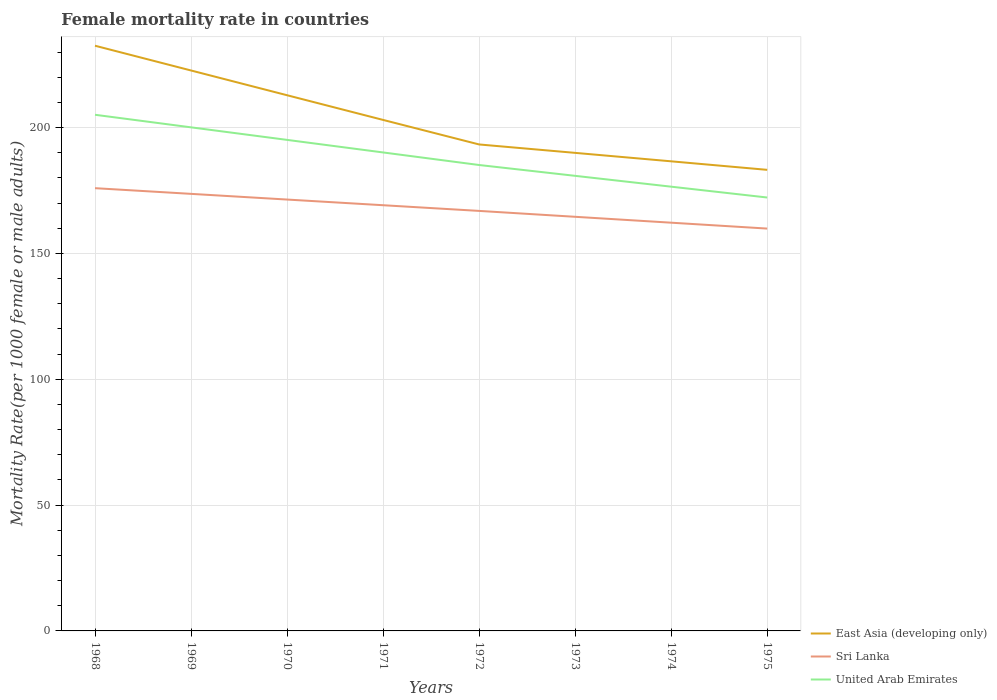Does the line corresponding to Sri Lanka intersect with the line corresponding to East Asia (developing only)?
Offer a very short reply. No. Across all years, what is the maximum female mortality rate in United Arab Emirates?
Make the answer very short. 172.23. In which year was the female mortality rate in Sri Lanka maximum?
Keep it short and to the point. 1975. What is the total female mortality rate in United Arab Emirates in the graph?
Your response must be concise. 12.92. What is the difference between the highest and the second highest female mortality rate in Sri Lanka?
Your answer should be compact. 16.06. What is the difference between the highest and the lowest female mortality rate in United Arab Emirates?
Ensure brevity in your answer.  4. Is the female mortality rate in Sri Lanka strictly greater than the female mortality rate in United Arab Emirates over the years?
Make the answer very short. Yes. How many years are there in the graph?
Give a very brief answer. 8. Are the values on the major ticks of Y-axis written in scientific E-notation?
Your answer should be very brief. No. Where does the legend appear in the graph?
Your answer should be compact. Bottom right. How are the legend labels stacked?
Give a very brief answer. Vertical. What is the title of the graph?
Provide a succinct answer. Female mortality rate in countries. What is the label or title of the X-axis?
Your answer should be very brief. Years. What is the label or title of the Y-axis?
Your answer should be compact. Mortality Rate(per 1000 female or male adults). What is the Mortality Rate(per 1000 female or male adults) in East Asia (developing only) in 1968?
Your answer should be compact. 232.55. What is the Mortality Rate(per 1000 female or male adults) of Sri Lanka in 1968?
Your answer should be very brief. 175.94. What is the Mortality Rate(per 1000 female or male adults) in United Arab Emirates in 1968?
Your answer should be very brief. 205.11. What is the Mortality Rate(per 1000 female or male adults) of East Asia (developing only) in 1969?
Your answer should be very brief. 222.71. What is the Mortality Rate(per 1000 female or male adults) of Sri Lanka in 1969?
Make the answer very short. 173.68. What is the Mortality Rate(per 1000 female or male adults) of United Arab Emirates in 1969?
Your answer should be compact. 200.12. What is the Mortality Rate(per 1000 female or male adults) in East Asia (developing only) in 1970?
Keep it short and to the point. 212.87. What is the Mortality Rate(per 1000 female or male adults) of Sri Lanka in 1970?
Make the answer very short. 171.43. What is the Mortality Rate(per 1000 female or male adults) of United Arab Emirates in 1970?
Give a very brief answer. 195.13. What is the Mortality Rate(per 1000 female or male adults) of East Asia (developing only) in 1971?
Your answer should be compact. 203.06. What is the Mortality Rate(per 1000 female or male adults) of Sri Lanka in 1971?
Your answer should be very brief. 169.17. What is the Mortality Rate(per 1000 female or male adults) of United Arab Emirates in 1971?
Make the answer very short. 190.14. What is the Mortality Rate(per 1000 female or male adults) in East Asia (developing only) in 1972?
Keep it short and to the point. 193.32. What is the Mortality Rate(per 1000 female or male adults) of Sri Lanka in 1972?
Keep it short and to the point. 166.91. What is the Mortality Rate(per 1000 female or male adults) in United Arab Emirates in 1972?
Keep it short and to the point. 185.15. What is the Mortality Rate(per 1000 female or male adults) in East Asia (developing only) in 1973?
Provide a short and direct response. 189.97. What is the Mortality Rate(per 1000 female or male adults) in Sri Lanka in 1973?
Your answer should be very brief. 164.57. What is the Mortality Rate(per 1000 female or male adults) of United Arab Emirates in 1973?
Provide a short and direct response. 180.84. What is the Mortality Rate(per 1000 female or male adults) of East Asia (developing only) in 1974?
Your response must be concise. 186.62. What is the Mortality Rate(per 1000 female or male adults) in Sri Lanka in 1974?
Your response must be concise. 162.23. What is the Mortality Rate(per 1000 female or male adults) in United Arab Emirates in 1974?
Provide a short and direct response. 176.54. What is the Mortality Rate(per 1000 female or male adults) in East Asia (developing only) in 1975?
Your response must be concise. 183.23. What is the Mortality Rate(per 1000 female or male adults) in Sri Lanka in 1975?
Your response must be concise. 159.89. What is the Mortality Rate(per 1000 female or male adults) of United Arab Emirates in 1975?
Provide a succinct answer. 172.23. Across all years, what is the maximum Mortality Rate(per 1000 female or male adults) in East Asia (developing only)?
Your answer should be compact. 232.55. Across all years, what is the maximum Mortality Rate(per 1000 female or male adults) in Sri Lanka?
Offer a terse response. 175.94. Across all years, what is the maximum Mortality Rate(per 1000 female or male adults) of United Arab Emirates?
Your answer should be very brief. 205.11. Across all years, what is the minimum Mortality Rate(per 1000 female or male adults) of East Asia (developing only)?
Offer a very short reply. 183.23. Across all years, what is the minimum Mortality Rate(per 1000 female or male adults) of Sri Lanka?
Offer a terse response. 159.89. Across all years, what is the minimum Mortality Rate(per 1000 female or male adults) of United Arab Emirates?
Offer a very short reply. 172.23. What is the total Mortality Rate(per 1000 female or male adults) in East Asia (developing only) in the graph?
Your answer should be very brief. 1624.33. What is the total Mortality Rate(per 1000 female or male adults) of Sri Lanka in the graph?
Make the answer very short. 1343.81. What is the total Mortality Rate(per 1000 female or male adults) of United Arab Emirates in the graph?
Make the answer very short. 1505.26. What is the difference between the Mortality Rate(per 1000 female or male adults) of East Asia (developing only) in 1968 and that in 1969?
Offer a terse response. 9.84. What is the difference between the Mortality Rate(per 1000 female or male adults) of Sri Lanka in 1968 and that in 1969?
Keep it short and to the point. 2.26. What is the difference between the Mortality Rate(per 1000 female or male adults) in United Arab Emirates in 1968 and that in 1969?
Your answer should be very brief. 4.99. What is the difference between the Mortality Rate(per 1000 female or male adults) in East Asia (developing only) in 1968 and that in 1970?
Keep it short and to the point. 19.68. What is the difference between the Mortality Rate(per 1000 female or male adults) in Sri Lanka in 1968 and that in 1970?
Ensure brevity in your answer.  4.52. What is the difference between the Mortality Rate(per 1000 female or male adults) in United Arab Emirates in 1968 and that in 1970?
Ensure brevity in your answer.  9.98. What is the difference between the Mortality Rate(per 1000 female or male adults) in East Asia (developing only) in 1968 and that in 1971?
Provide a short and direct response. 29.49. What is the difference between the Mortality Rate(per 1000 female or male adults) in Sri Lanka in 1968 and that in 1971?
Provide a succinct answer. 6.77. What is the difference between the Mortality Rate(per 1000 female or male adults) in United Arab Emirates in 1968 and that in 1971?
Give a very brief answer. 14.97. What is the difference between the Mortality Rate(per 1000 female or male adults) of East Asia (developing only) in 1968 and that in 1972?
Ensure brevity in your answer.  39.24. What is the difference between the Mortality Rate(per 1000 female or male adults) in Sri Lanka in 1968 and that in 1972?
Offer a terse response. 9.03. What is the difference between the Mortality Rate(per 1000 female or male adults) of United Arab Emirates in 1968 and that in 1972?
Provide a short and direct response. 19.96. What is the difference between the Mortality Rate(per 1000 female or male adults) in East Asia (developing only) in 1968 and that in 1973?
Your answer should be compact. 42.58. What is the difference between the Mortality Rate(per 1000 female or male adults) of Sri Lanka in 1968 and that in 1973?
Make the answer very short. 11.37. What is the difference between the Mortality Rate(per 1000 female or male adults) in United Arab Emirates in 1968 and that in 1973?
Offer a terse response. 24.27. What is the difference between the Mortality Rate(per 1000 female or male adults) in East Asia (developing only) in 1968 and that in 1974?
Give a very brief answer. 45.94. What is the difference between the Mortality Rate(per 1000 female or male adults) of Sri Lanka in 1968 and that in 1974?
Keep it short and to the point. 13.71. What is the difference between the Mortality Rate(per 1000 female or male adults) of United Arab Emirates in 1968 and that in 1974?
Provide a succinct answer. 28.57. What is the difference between the Mortality Rate(per 1000 female or male adults) in East Asia (developing only) in 1968 and that in 1975?
Your answer should be compact. 49.33. What is the difference between the Mortality Rate(per 1000 female or male adults) of Sri Lanka in 1968 and that in 1975?
Make the answer very short. 16.05. What is the difference between the Mortality Rate(per 1000 female or male adults) of United Arab Emirates in 1968 and that in 1975?
Your answer should be compact. 32.88. What is the difference between the Mortality Rate(per 1000 female or male adults) in East Asia (developing only) in 1969 and that in 1970?
Your answer should be compact. 9.83. What is the difference between the Mortality Rate(per 1000 female or male adults) in Sri Lanka in 1969 and that in 1970?
Offer a terse response. 2.26. What is the difference between the Mortality Rate(per 1000 female or male adults) of United Arab Emirates in 1969 and that in 1970?
Your answer should be compact. 4.99. What is the difference between the Mortality Rate(per 1000 female or male adults) in East Asia (developing only) in 1969 and that in 1971?
Offer a very short reply. 19.64. What is the difference between the Mortality Rate(per 1000 female or male adults) in Sri Lanka in 1969 and that in 1971?
Ensure brevity in your answer.  4.52. What is the difference between the Mortality Rate(per 1000 female or male adults) in United Arab Emirates in 1969 and that in 1971?
Ensure brevity in your answer.  9.98. What is the difference between the Mortality Rate(per 1000 female or male adults) of East Asia (developing only) in 1969 and that in 1972?
Offer a very short reply. 29.39. What is the difference between the Mortality Rate(per 1000 female or male adults) of Sri Lanka in 1969 and that in 1972?
Keep it short and to the point. 6.77. What is the difference between the Mortality Rate(per 1000 female or male adults) of United Arab Emirates in 1969 and that in 1972?
Ensure brevity in your answer.  14.97. What is the difference between the Mortality Rate(per 1000 female or male adults) of East Asia (developing only) in 1969 and that in 1973?
Provide a succinct answer. 32.73. What is the difference between the Mortality Rate(per 1000 female or male adults) of Sri Lanka in 1969 and that in 1973?
Your answer should be very brief. 9.12. What is the difference between the Mortality Rate(per 1000 female or male adults) of United Arab Emirates in 1969 and that in 1973?
Offer a terse response. 19.28. What is the difference between the Mortality Rate(per 1000 female or male adults) in East Asia (developing only) in 1969 and that in 1974?
Ensure brevity in your answer.  36.09. What is the difference between the Mortality Rate(per 1000 female or male adults) of Sri Lanka in 1969 and that in 1974?
Your response must be concise. 11.46. What is the difference between the Mortality Rate(per 1000 female or male adults) of United Arab Emirates in 1969 and that in 1974?
Ensure brevity in your answer.  23.58. What is the difference between the Mortality Rate(per 1000 female or male adults) of East Asia (developing only) in 1969 and that in 1975?
Provide a succinct answer. 39.48. What is the difference between the Mortality Rate(per 1000 female or male adults) in Sri Lanka in 1969 and that in 1975?
Offer a very short reply. 13.8. What is the difference between the Mortality Rate(per 1000 female or male adults) of United Arab Emirates in 1969 and that in 1975?
Your answer should be compact. 27.89. What is the difference between the Mortality Rate(per 1000 female or male adults) of East Asia (developing only) in 1970 and that in 1971?
Your answer should be compact. 9.81. What is the difference between the Mortality Rate(per 1000 female or male adults) in Sri Lanka in 1970 and that in 1971?
Offer a very short reply. 2.26. What is the difference between the Mortality Rate(per 1000 female or male adults) of United Arab Emirates in 1970 and that in 1971?
Provide a succinct answer. 4.99. What is the difference between the Mortality Rate(per 1000 female or male adults) of East Asia (developing only) in 1970 and that in 1972?
Provide a succinct answer. 19.56. What is the difference between the Mortality Rate(per 1000 female or male adults) of Sri Lanka in 1970 and that in 1972?
Provide a short and direct response. 4.52. What is the difference between the Mortality Rate(per 1000 female or male adults) of United Arab Emirates in 1970 and that in 1972?
Your answer should be compact. 9.98. What is the difference between the Mortality Rate(per 1000 female or male adults) of East Asia (developing only) in 1970 and that in 1973?
Offer a very short reply. 22.9. What is the difference between the Mortality Rate(per 1000 female or male adults) in Sri Lanka in 1970 and that in 1973?
Offer a very short reply. 6.86. What is the difference between the Mortality Rate(per 1000 female or male adults) in United Arab Emirates in 1970 and that in 1973?
Give a very brief answer. 14.29. What is the difference between the Mortality Rate(per 1000 female or male adults) in East Asia (developing only) in 1970 and that in 1974?
Your response must be concise. 26.26. What is the difference between the Mortality Rate(per 1000 female or male adults) of Sri Lanka in 1970 and that in 1974?
Your response must be concise. 9.2. What is the difference between the Mortality Rate(per 1000 female or male adults) in United Arab Emirates in 1970 and that in 1974?
Your answer should be very brief. 18.59. What is the difference between the Mortality Rate(per 1000 female or male adults) in East Asia (developing only) in 1970 and that in 1975?
Offer a terse response. 29.65. What is the difference between the Mortality Rate(per 1000 female or male adults) of Sri Lanka in 1970 and that in 1975?
Offer a terse response. 11.54. What is the difference between the Mortality Rate(per 1000 female or male adults) in United Arab Emirates in 1970 and that in 1975?
Make the answer very short. 22.9. What is the difference between the Mortality Rate(per 1000 female or male adults) in East Asia (developing only) in 1971 and that in 1972?
Offer a very short reply. 9.75. What is the difference between the Mortality Rate(per 1000 female or male adults) in Sri Lanka in 1971 and that in 1972?
Keep it short and to the point. 2.26. What is the difference between the Mortality Rate(per 1000 female or male adults) of United Arab Emirates in 1971 and that in 1972?
Provide a short and direct response. 4.99. What is the difference between the Mortality Rate(per 1000 female or male adults) in East Asia (developing only) in 1971 and that in 1973?
Offer a terse response. 13.09. What is the difference between the Mortality Rate(per 1000 female or male adults) of Sri Lanka in 1971 and that in 1973?
Provide a succinct answer. 4.6. What is the difference between the Mortality Rate(per 1000 female or male adults) in United Arab Emirates in 1971 and that in 1973?
Your answer should be very brief. 9.3. What is the difference between the Mortality Rate(per 1000 female or male adults) of East Asia (developing only) in 1971 and that in 1974?
Ensure brevity in your answer.  16.45. What is the difference between the Mortality Rate(per 1000 female or male adults) in Sri Lanka in 1971 and that in 1974?
Offer a very short reply. 6.94. What is the difference between the Mortality Rate(per 1000 female or male adults) of United Arab Emirates in 1971 and that in 1974?
Offer a very short reply. 13.6. What is the difference between the Mortality Rate(per 1000 female or male adults) of East Asia (developing only) in 1971 and that in 1975?
Your response must be concise. 19.84. What is the difference between the Mortality Rate(per 1000 female or male adults) of Sri Lanka in 1971 and that in 1975?
Your response must be concise. 9.28. What is the difference between the Mortality Rate(per 1000 female or male adults) in United Arab Emirates in 1971 and that in 1975?
Offer a very short reply. 17.91. What is the difference between the Mortality Rate(per 1000 female or male adults) in East Asia (developing only) in 1972 and that in 1973?
Your answer should be compact. 3.34. What is the difference between the Mortality Rate(per 1000 female or male adults) of Sri Lanka in 1972 and that in 1973?
Ensure brevity in your answer.  2.34. What is the difference between the Mortality Rate(per 1000 female or male adults) of United Arab Emirates in 1972 and that in 1973?
Offer a very short reply. 4.3. What is the difference between the Mortality Rate(per 1000 female or male adults) in East Asia (developing only) in 1972 and that in 1974?
Your answer should be compact. 6.7. What is the difference between the Mortality Rate(per 1000 female or male adults) in Sri Lanka in 1972 and that in 1974?
Make the answer very short. 4.68. What is the difference between the Mortality Rate(per 1000 female or male adults) in United Arab Emirates in 1972 and that in 1974?
Provide a short and direct response. 8.61. What is the difference between the Mortality Rate(per 1000 female or male adults) of East Asia (developing only) in 1972 and that in 1975?
Your answer should be very brief. 10.09. What is the difference between the Mortality Rate(per 1000 female or male adults) in Sri Lanka in 1972 and that in 1975?
Your answer should be very brief. 7.02. What is the difference between the Mortality Rate(per 1000 female or male adults) in United Arab Emirates in 1972 and that in 1975?
Provide a short and direct response. 12.92. What is the difference between the Mortality Rate(per 1000 female or male adults) of East Asia (developing only) in 1973 and that in 1974?
Provide a short and direct response. 3.36. What is the difference between the Mortality Rate(per 1000 female or male adults) in Sri Lanka in 1973 and that in 1974?
Provide a succinct answer. 2.34. What is the difference between the Mortality Rate(per 1000 female or male adults) in United Arab Emirates in 1973 and that in 1974?
Make the answer very short. 4.31. What is the difference between the Mortality Rate(per 1000 female or male adults) in East Asia (developing only) in 1973 and that in 1975?
Keep it short and to the point. 6.75. What is the difference between the Mortality Rate(per 1000 female or male adults) in Sri Lanka in 1973 and that in 1975?
Your answer should be compact. 4.68. What is the difference between the Mortality Rate(per 1000 female or male adults) of United Arab Emirates in 1973 and that in 1975?
Offer a terse response. 8.61. What is the difference between the Mortality Rate(per 1000 female or male adults) in East Asia (developing only) in 1974 and that in 1975?
Make the answer very short. 3.39. What is the difference between the Mortality Rate(per 1000 female or male adults) in Sri Lanka in 1974 and that in 1975?
Give a very brief answer. 2.34. What is the difference between the Mortality Rate(per 1000 female or male adults) in United Arab Emirates in 1974 and that in 1975?
Your answer should be very brief. 4.31. What is the difference between the Mortality Rate(per 1000 female or male adults) in East Asia (developing only) in 1968 and the Mortality Rate(per 1000 female or male adults) in Sri Lanka in 1969?
Your answer should be compact. 58.87. What is the difference between the Mortality Rate(per 1000 female or male adults) in East Asia (developing only) in 1968 and the Mortality Rate(per 1000 female or male adults) in United Arab Emirates in 1969?
Your answer should be very brief. 32.43. What is the difference between the Mortality Rate(per 1000 female or male adults) of Sri Lanka in 1968 and the Mortality Rate(per 1000 female or male adults) of United Arab Emirates in 1969?
Provide a succinct answer. -24.18. What is the difference between the Mortality Rate(per 1000 female or male adults) in East Asia (developing only) in 1968 and the Mortality Rate(per 1000 female or male adults) in Sri Lanka in 1970?
Provide a succinct answer. 61.13. What is the difference between the Mortality Rate(per 1000 female or male adults) in East Asia (developing only) in 1968 and the Mortality Rate(per 1000 female or male adults) in United Arab Emirates in 1970?
Offer a terse response. 37.42. What is the difference between the Mortality Rate(per 1000 female or male adults) of Sri Lanka in 1968 and the Mortality Rate(per 1000 female or male adults) of United Arab Emirates in 1970?
Your response must be concise. -19.19. What is the difference between the Mortality Rate(per 1000 female or male adults) in East Asia (developing only) in 1968 and the Mortality Rate(per 1000 female or male adults) in Sri Lanka in 1971?
Your answer should be compact. 63.39. What is the difference between the Mortality Rate(per 1000 female or male adults) in East Asia (developing only) in 1968 and the Mortality Rate(per 1000 female or male adults) in United Arab Emirates in 1971?
Ensure brevity in your answer.  42.41. What is the difference between the Mortality Rate(per 1000 female or male adults) in Sri Lanka in 1968 and the Mortality Rate(per 1000 female or male adults) in United Arab Emirates in 1971?
Offer a very short reply. -14.2. What is the difference between the Mortality Rate(per 1000 female or male adults) in East Asia (developing only) in 1968 and the Mortality Rate(per 1000 female or male adults) in Sri Lanka in 1972?
Ensure brevity in your answer.  65.64. What is the difference between the Mortality Rate(per 1000 female or male adults) of East Asia (developing only) in 1968 and the Mortality Rate(per 1000 female or male adults) of United Arab Emirates in 1972?
Ensure brevity in your answer.  47.4. What is the difference between the Mortality Rate(per 1000 female or male adults) of Sri Lanka in 1968 and the Mortality Rate(per 1000 female or male adults) of United Arab Emirates in 1972?
Ensure brevity in your answer.  -9.21. What is the difference between the Mortality Rate(per 1000 female or male adults) in East Asia (developing only) in 1968 and the Mortality Rate(per 1000 female or male adults) in Sri Lanka in 1973?
Provide a short and direct response. 67.98. What is the difference between the Mortality Rate(per 1000 female or male adults) of East Asia (developing only) in 1968 and the Mortality Rate(per 1000 female or male adults) of United Arab Emirates in 1973?
Give a very brief answer. 51.71. What is the difference between the Mortality Rate(per 1000 female or male adults) in Sri Lanka in 1968 and the Mortality Rate(per 1000 female or male adults) in United Arab Emirates in 1973?
Your answer should be compact. -4.9. What is the difference between the Mortality Rate(per 1000 female or male adults) in East Asia (developing only) in 1968 and the Mortality Rate(per 1000 female or male adults) in Sri Lanka in 1974?
Make the answer very short. 70.33. What is the difference between the Mortality Rate(per 1000 female or male adults) of East Asia (developing only) in 1968 and the Mortality Rate(per 1000 female or male adults) of United Arab Emirates in 1974?
Offer a very short reply. 56.02. What is the difference between the Mortality Rate(per 1000 female or male adults) of Sri Lanka in 1968 and the Mortality Rate(per 1000 female or male adults) of United Arab Emirates in 1974?
Keep it short and to the point. -0.6. What is the difference between the Mortality Rate(per 1000 female or male adults) in East Asia (developing only) in 1968 and the Mortality Rate(per 1000 female or male adults) in Sri Lanka in 1975?
Your response must be concise. 72.67. What is the difference between the Mortality Rate(per 1000 female or male adults) of East Asia (developing only) in 1968 and the Mortality Rate(per 1000 female or male adults) of United Arab Emirates in 1975?
Keep it short and to the point. 60.32. What is the difference between the Mortality Rate(per 1000 female or male adults) in Sri Lanka in 1968 and the Mortality Rate(per 1000 female or male adults) in United Arab Emirates in 1975?
Your response must be concise. 3.71. What is the difference between the Mortality Rate(per 1000 female or male adults) of East Asia (developing only) in 1969 and the Mortality Rate(per 1000 female or male adults) of Sri Lanka in 1970?
Your answer should be compact. 51.28. What is the difference between the Mortality Rate(per 1000 female or male adults) in East Asia (developing only) in 1969 and the Mortality Rate(per 1000 female or male adults) in United Arab Emirates in 1970?
Provide a short and direct response. 27.58. What is the difference between the Mortality Rate(per 1000 female or male adults) in Sri Lanka in 1969 and the Mortality Rate(per 1000 female or male adults) in United Arab Emirates in 1970?
Give a very brief answer. -21.45. What is the difference between the Mortality Rate(per 1000 female or male adults) of East Asia (developing only) in 1969 and the Mortality Rate(per 1000 female or male adults) of Sri Lanka in 1971?
Your response must be concise. 53.54. What is the difference between the Mortality Rate(per 1000 female or male adults) of East Asia (developing only) in 1969 and the Mortality Rate(per 1000 female or male adults) of United Arab Emirates in 1971?
Offer a very short reply. 32.57. What is the difference between the Mortality Rate(per 1000 female or male adults) of Sri Lanka in 1969 and the Mortality Rate(per 1000 female or male adults) of United Arab Emirates in 1971?
Offer a terse response. -16.46. What is the difference between the Mortality Rate(per 1000 female or male adults) of East Asia (developing only) in 1969 and the Mortality Rate(per 1000 female or male adults) of Sri Lanka in 1972?
Offer a terse response. 55.8. What is the difference between the Mortality Rate(per 1000 female or male adults) in East Asia (developing only) in 1969 and the Mortality Rate(per 1000 female or male adults) in United Arab Emirates in 1972?
Your answer should be compact. 37.56. What is the difference between the Mortality Rate(per 1000 female or male adults) of Sri Lanka in 1969 and the Mortality Rate(per 1000 female or male adults) of United Arab Emirates in 1972?
Your answer should be very brief. -11.46. What is the difference between the Mortality Rate(per 1000 female or male adults) in East Asia (developing only) in 1969 and the Mortality Rate(per 1000 female or male adults) in Sri Lanka in 1973?
Give a very brief answer. 58.14. What is the difference between the Mortality Rate(per 1000 female or male adults) in East Asia (developing only) in 1969 and the Mortality Rate(per 1000 female or male adults) in United Arab Emirates in 1973?
Provide a succinct answer. 41.87. What is the difference between the Mortality Rate(per 1000 female or male adults) in Sri Lanka in 1969 and the Mortality Rate(per 1000 female or male adults) in United Arab Emirates in 1973?
Keep it short and to the point. -7.16. What is the difference between the Mortality Rate(per 1000 female or male adults) in East Asia (developing only) in 1969 and the Mortality Rate(per 1000 female or male adults) in Sri Lanka in 1974?
Offer a terse response. 60.48. What is the difference between the Mortality Rate(per 1000 female or male adults) in East Asia (developing only) in 1969 and the Mortality Rate(per 1000 female or male adults) in United Arab Emirates in 1974?
Provide a succinct answer. 46.17. What is the difference between the Mortality Rate(per 1000 female or male adults) of Sri Lanka in 1969 and the Mortality Rate(per 1000 female or male adults) of United Arab Emirates in 1974?
Make the answer very short. -2.85. What is the difference between the Mortality Rate(per 1000 female or male adults) of East Asia (developing only) in 1969 and the Mortality Rate(per 1000 female or male adults) of Sri Lanka in 1975?
Give a very brief answer. 62.82. What is the difference between the Mortality Rate(per 1000 female or male adults) of East Asia (developing only) in 1969 and the Mortality Rate(per 1000 female or male adults) of United Arab Emirates in 1975?
Your response must be concise. 50.48. What is the difference between the Mortality Rate(per 1000 female or male adults) in Sri Lanka in 1969 and the Mortality Rate(per 1000 female or male adults) in United Arab Emirates in 1975?
Ensure brevity in your answer.  1.45. What is the difference between the Mortality Rate(per 1000 female or male adults) in East Asia (developing only) in 1970 and the Mortality Rate(per 1000 female or male adults) in Sri Lanka in 1971?
Keep it short and to the point. 43.71. What is the difference between the Mortality Rate(per 1000 female or male adults) in East Asia (developing only) in 1970 and the Mortality Rate(per 1000 female or male adults) in United Arab Emirates in 1971?
Keep it short and to the point. 22.73. What is the difference between the Mortality Rate(per 1000 female or male adults) in Sri Lanka in 1970 and the Mortality Rate(per 1000 female or male adults) in United Arab Emirates in 1971?
Your answer should be compact. -18.71. What is the difference between the Mortality Rate(per 1000 female or male adults) of East Asia (developing only) in 1970 and the Mortality Rate(per 1000 female or male adults) of Sri Lanka in 1972?
Keep it short and to the point. 45.97. What is the difference between the Mortality Rate(per 1000 female or male adults) in East Asia (developing only) in 1970 and the Mortality Rate(per 1000 female or male adults) in United Arab Emirates in 1972?
Offer a very short reply. 27.73. What is the difference between the Mortality Rate(per 1000 female or male adults) of Sri Lanka in 1970 and the Mortality Rate(per 1000 female or male adults) of United Arab Emirates in 1972?
Your answer should be very brief. -13.72. What is the difference between the Mortality Rate(per 1000 female or male adults) of East Asia (developing only) in 1970 and the Mortality Rate(per 1000 female or male adults) of Sri Lanka in 1973?
Keep it short and to the point. 48.31. What is the difference between the Mortality Rate(per 1000 female or male adults) in East Asia (developing only) in 1970 and the Mortality Rate(per 1000 female or male adults) in United Arab Emirates in 1973?
Your response must be concise. 32.03. What is the difference between the Mortality Rate(per 1000 female or male adults) in Sri Lanka in 1970 and the Mortality Rate(per 1000 female or male adults) in United Arab Emirates in 1973?
Provide a succinct answer. -9.42. What is the difference between the Mortality Rate(per 1000 female or male adults) in East Asia (developing only) in 1970 and the Mortality Rate(per 1000 female or male adults) in Sri Lanka in 1974?
Give a very brief answer. 50.65. What is the difference between the Mortality Rate(per 1000 female or male adults) in East Asia (developing only) in 1970 and the Mortality Rate(per 1000 female or male adults) in United Arab Emirates in 1974?
Your answer should be very brief. 36.34. What is the difference between the Mortality Rate(per 1000 female or male adults) in Sri Lanka in 1970 and the Mortality Rate(per 1000 female or male adults) in United Arab Emirates in 1974?
Offer a very short reply. -5.11. What is the difference between the Mortality Rate(per 1000 female or male adults) in East Asia (developing only) in 1970 and the Mortality Rate(per 1000 female or male adults) in Sri Lanka in 1975?
Your answer should be compact. 52.99. What is the difference between the Mortality Rate(per 1000 female or male adults) in East Asia (developing only) in 1970 and the Mortality Rate(per 1000 female or male adults) in United Arab Emirates in 1975?
Your answer should be very brief. 40.64. What is the difference between the Mortality Rate(per 1000 female or male adults) of Sri Lanka in 1970 and the Mortality Rate(per 1000 female or male adults) of United Arab Emirates in 1975?
Offer a very short reply. -0.81. What is the difference between the Mortality Rate(per 1000 female or male adults) in East Asia (developing only) in 1971 and the Mortality Rate(per 1000 female or male adults) in Sri Lanka in 1972?
Offer a terse response. 36.15. What is the difference between the Mortality Rate(per 1000 female or male adults) in East Asia (developing only) in 1971 and the Mortality Rate(per 1000 female or male adults) in United Arab Emirates in 1972?
Offer a terse response. 17.92. What is the difference between the Mortality Rate(per 1000 female or male adults) in Sri Lanka in 1971 and the Mortality Rate(per 1000 female or male adults) in United Arab Emirates in 1972?
Offer a terse response. -15.98. What is the difference between the Mortality Rate(per 1000 female or male adults) in East Asia (developing only) in 1971 and the Mortality Rate(per 1000 female or male adults) in Sri Lanka in 1973?
Ensure brevity in your answer.  38.5. What is the difference between the Mortality Rate(per 1000 female or male adults) of East Asia (developing only) in 1971 and the Mortality Rate(per 1000 female or male adults) of United Arab Emirates in 1973?
Give a very brief answer. 22.22. What is the difference between the Mortality Rate(per 1000 female or male adults) of Sri Lanka in 1971 and the Mortality Rate(per 1000 female or male adults) of United Arab Emirates in 1973?
Your answer should be compact. -11.68. What is the difference between the Mortality Rate(per 1000 female or male adults) in East Asia (developing only) in 1971 and the Mortality Rate(per 1000 female or male adults) in Sri Lanka in 1974?
Offer a terse response. 40.84. What is the difference between the Mortality Rate(per 1000 female or male adults) in East Asia (developing only) in 1971 and the Mortality Rate(per 1000 female or male adults) in United Arab Emirates in 1974?
Your answer should be very brief. 26.53. What is the difference between the Mortality Rate(per 1000 female or male adults) in Sri Lanka in 1971 and the Mortality Rate(per 1000 female or male adults) in United Arab Emirates in 1974?
Provide a succinct answer. -7.37. What is the difference between the Mortality Rate(per 1000 female or male adults) of East Asia (developing only) in 1971 and the Mortality Rate(per 1000 female or male adults) of Sri Lanka in 1975?
Give a very brief answer. 43.18. What is the difference between the Mortality Rate(per 1000 female or male adults) in East Asia (developing only) in 1971 and the Mortality Rate(per 1000 female or male adults) in United Arab Emirates in 1975?
Offer a very short reply. 30.83. What is the difference between the Mortality Rate(per 1000 female or male adults) in Sri Lanka in 1971 and the Mortality Rate(per 1000 female or male adults) in United Arab Emirates in 1975?
Your answer should be compact. -3.06. What is the difference between the Mortality Rate(per 1000 female or male adults) of East Asia (developing only) in 1972 and the Mortality Rate(per 1000 female or male adults) of Sri Lanka in 1973?
Offer a terse response. 28.75. What is the difference between the Mortality Rate(per 1000 female or male adults) of East Asia (developing only) in 1972 and the Mortality Rate(per 1000 female or male adults) of United Arab Emirates in 1973?
Provide a short and direct response. 12.47. What is the difference between the Mortality Rate(per 1000 female or male adults) of Sri Lanka in 1972 and the Mortality Rate(per 1000 female or male adults) of United Arab Emirates in 1973?
Your answer should be very brief. -13.93. What is the difference between the Mortality Rate(per 1000 female or male adults) of East Asia (developing only) in 1972 and the Mortality Rate(per 1000 female or male adults) of Sri Lanka in 1974?
Provide a succinct answer. 31.09. What is the difference between the Mortality Rate(per 1000 female or male adults) of East Asia (developing only) in 1972 and the Mortality Rate(per 1000 female or male adults) of United Arab Emirates in 1974?
Offer a very short reply. 16.78. What is the difference between the Mortality Rate(per 1000 female or male adults) of Sri Lanka in 1972 and the Mortality Rate(per 1000 female or male adults) of United Arab Emirates in 1974?
Your answer should be compact. -9.63. What is the difference between the Mortality Rate(per 1000 female or male adults) in East Asia (developing only) in 1972 and the Mortality Rate(per 1000 female or male adults) in Sri Lanka in 1975?
Ensure brevity in your answer.  33.43. What is the difference between the Mortality Rate(per 1000 female or male adults) in East Asia (developing only) in 1972 and the Mortality Rate(per 1000 female or male adults) in United Arab Emirates in 1975?
Your answer should be very brief. 21.08. What is the difference between the Mortality Rate(per 1000 female or male adults) of Sri Lanka in 1972 and the Mortality Rate(per 1000 female or male adults) of United Arab Emirates in 1975?
Offer a terse response. -5.32. What is the difference between the Mortality Rate(per 1000 female or male adults) in East Asia (developing only) in 1973 and the Mortality Rate(per 1000 female or male adults) in Sri Lanka in 1974?
Make the answer very short. 27.75. What is the difference between the Mortality Rate(per 1000 female or male adults) in East Asia (developing only) in 1973 and the Mortality Rate(per 1000 female or male adults) in United Arab Emirates in 1974?
Offer a very short reply. 13.44. What is the difference between the Mortality Rate(per 1000 female or male adults) in Sri Lanka in 1973 and the Mortality Rate(per 1000 female or male adults) in United Arab Emirates in 1974?
Keep it short and to the point. -11.97. What is the difference between the Mortality Rate(per 1000 female or male adults) in East Asia (developing only) in 1973 and the Mortality Rate(per 1000 female or male adults) in Sri Lanka in 1975?
Your answer should be very brief. 30.09. What is the difference between the Mortality Rate(per 1000 female or male adults) of East Asia (developing only) in 1973 and the Mortality Rate(per 1000 female or male adults) of United Arab Emirates in 1975?
Keep it short and to the point. 17.74. What is the difference between the Mortality Rate(per 1000 female or male adults) in Sri Lanka in 1973 and the Mortality Rate(per 1000 female or male adults) in United Arab Emirates in 1975?
Provide a short and direct response. -7.66. What is the difference between the Mortality Rate(per 1000 female or male adults) in East Asia (developing only) in 1974 and the Mortality Rate(per 1000 female or male adults) in Sri Lanka in 1975?
Provide a short and direct response. 26.73. What is the difference between the Mortality Rate(per 1000 female or male adults) of East Asia (developing only) in 1974 and the Mortality Rate(per 1000 female or male adults) of United Arab Emirates in 1975?
Your answer should be very brief. 14.38. What is the difference between the Mortality Rate(per 1000 female or male adults) of Sri Lanka in 1974 and the Mortality Rate(per 1000 female or male adults) of United Arab Emirates in 1975?
Offer a very short reply. -10. What is the average Mortality Rate(per 1000 female or male adults) of East Asia (developing only) per year?
Provide a succinct answer. 203.04. What is the average Mortality Rate(per 1000 female or male adults) in Sri Lanka per year?
Keep it short and to the point. 167.98. What is the average Mortality Rate(per 1000 female or male adults) in United Arab Emirates per year?
Offer a terse response. 188.16. In the year 1968, what is the difference between the Mortality Rate(per 1000 female or male adults) in East Asia (developing only) and Mortality Rate(per 1000 female or male adults) in Sri Lanka?
Make the answer very short. 56.61. In the year 1968, what is the difference between the Mortality Rate(per 1000 female or male adults) of East Asia (developing only) and Mortality Rate(per 1000 female or male adults) of United Arab Emirates?
Provide a succinct answer. 27.44. In the year 1968, what is the difference between the Mortality Rate(per 1000 female or male adults) in Sri Lanka and Mortality Rate(per 1000 female or male adults) in United Arab Emirates?
Make the answer very short. -29.17. In the year 1969, what is the difference between the Mortality Rate(per 1000 female or male adults) of East Asia (developing only) and Mortality Rate(per 1000 female or male adults) of Sri Lanka?
Make the answer very short. 49.03. In the year 1969, what is the difference between the Mortality Rate(per 1000 female or male adults) of East Asia (developing only) and Mortality Rate(per 1000 female or male adults) of United Arab Emirates?
Your answer should be compact. 22.59. In the year 1969, what is the difference between the Mortality Rate(per 1000 female or male adults) in Sri Lanka and Mortality Rate(per 1000 female or male adults) in United Arab Emirates?
Make the answer very short. -26.44. In the year 1970, what is the difference between the Mortality Rate(per 1000 female or male adults) in East Asia (developing only) and Mortality Rate(per 1000 female or male adults) in Sri Lanka?
Offer a very short reply. 41.45. In the year 1970, what is the difference between the Mortality Rate(per 1000 female or male adults) of East Asia (developing only) and Mortality Rate(per 1000 female or male adults) of United Arab Emirates?
Your answer should be very brief. 17.74. In the year 1970, what is the difference between the Mortality Rate(per 1000 female or male adults) in Sri Lanka and Mortality Rate(per 1000 female or male adults) in United Arab Emirates?
Ensure brevity in your answer.  -23.7. In the year 1971, what is the difference between the Mortality Rate(per 1000 female or male adults) of East Asia (developing only) and Mortality Rate(per 1000 female or male adults) of Sri Lanka?
Offer a very short reply. 33.9. In the year 1971, what is the difference between the Mortality Rate(per 1000 female or male adults) in East Asia (developing only) and Mortality Rate(per 1000 female or male adults) in United Arab Emirates?
Offer a terse response. 12.92. In the year 1971, what is the difference between the Mortality Rate(per 1000 female or male adults) of Sri Lanka and Mortality Rate(per 1000 female or male adults) of United Arab Emirates?
Make the answer very short. -20.97. In the year 1972, what is the difference between the Mortality Rate(per 1000 female or male adults) in East Asia (developing only) and Mortality Rate(per 1000 female or male adults) in Sri Lanka?
Give a very brief answer. 26.41. In the year 1972, what is the difference between the Mortality Rate(per 1000 female or male adults) in East Asia (developing only) and Mortality Rate(per 1000 female or male adults) in United Arab Emirates?
Offer a very short reply. 8.17. In the year 1972, what is the difference between the Mortality Rate(per 1000 female or male adults) in Sri Lanka and Mortality Rate(per 1000 female or male adults) in United Arab Emirates?
Provide a succinct answer. -18.24. In the year 1973, what is the difference between the Mortality Rate(per 1000 female or male adults) of East Asia (developing only) and Mortality Rate(per 1000 female or male adults) of Sri Lanka?
Give a very brief answer. 25.41. In the year 1973, what is the difference between the Mortality Rate(per 1000 female or male adults) in East Asia (developing only) and Mortality Rate(per 1000 female or male adults) in United Arab Emirates?
Keep it short and to the point. 9.13. In the year 1973, what is the difference between the Mortality Rate(per 1000 female or male adults) in Sri Lanka and Mortality Rate(per 1000 female or male adults) in United Arab Emirates?
Offer a terse response. -16.27. In the year 1974, what is the difference between the Mortality Rate(per 1000 female or male adults) of East Asia (developing only) and Mortality Rate(per 1000 female or male adults) of Sri Lanka?
Ensure brevity in your answer.  24.39. In the year 1974, what is the difference between the Mortality Rate(per 1000 female or male adults) of East Asia (developing only) and Mortality Rate(per 1000 female or male adults) of United Arab Emirates?
Your response must be concise. 10.08. In the year 1974, what is the difference between the Mortality Rate(per 1000 female or male adults) of Sri Lanka and Mortality Rate(per 1000 female or male adults) of United Arab Emirates?
Keep it short and to the point. -14.31. In the year 1975, what is the difference between the Mortality Rate(per 1000 female or male adults) in East Asia (developing only) and Mortality Rate(per 1000 female or male adults) in Sri Lanka?
Offer a very short reply. 23.34. In the year 1975, what is the difference between the Mortality Rate(per 1000 female or male adults) of East Asia (developing only) and Mortality Rate(per 1000 female or male adults) of United Arab Emirates?
Offer a terse response. 11. In the year 1975, what is the difference between the Mortality Rate(per 1000 female or male adults) in Sri Lanka and Mortality Rate(per 1000 female or male adults) in United Arab Emirates?
Offer a terse response. -12.35. What is the ratio of the Mortality Rate(per 1000 female or male adults) in East Asia (developing only) in 1968 to that in 1969?
Offer a very short reply. 1.04. What is the ratio of the Mortality Rate(per 1000 female or male adults) in United Arab Emirates in 1968 to that in 1969?
Ensure brevity in your answer.  1.02. What is the ratio of the Mortality Rate(per 1000 female or male adults) in East Asia (developing only) in 1968 to that in 1970?
Keep it short and to the point. 1.09. What is the ratio of the Mortality Rate(per 1000 female or male adults) in Sri Lanka in 1968 to that in 1970?
Your answer should be compact. 1.03. What is the ratio of the Mortality Rate(per 1000 female or male adults) of United Arab Emirates in 1968 to that in 1970?
Your answer should be very brief. 1.05. What is the ratio of the Mortality Rate(per 1000 female or male adults) of East Asia (developing only) in 1968 to that in 1971?
Your answer should be compact. 1.15. What is the ratio of the Mortality Rate(per 1000 female or male adults) in Sri Lanka in 1968 to that in 1971?
Offer a very short reply. 1.04. What is the ratio of the Mortality Rate(per 1000 female or male adults) of United Arab Emirates in 1968 to that in 1971?
Offer a terse response. 1.08. What is the ratio of the Mortality Rate(per 1000 female or male adults) of East Asia (developing only) in 1968 to that in 1972?
Ensure brevity in your answer.  1.2. What is the ratio of the Mortality Rate(per 1000 female or male adults) of Sri Lanka in 1968 to that in 1972?
Provide a short and direct response. 1.05. What is the ratio of the Mortality Rate(per 1000 female or male adults) in United Arab Emirates in 1968 to that in 1972?
Your answer should be compact. 1.11. What is the ratio of the Mortality Rate(per 1000 female or male adults) of East Asia (developing only) in 1968 to that in 1973?
Offer a very short reply. 1.22. What is the ratio of the Mortality Rate(per 1000 female or male adults) of Sri Lanka in 1968 to that in 1973?
Provide a short and direct response. 1.07. What is the ratio of the Mortality Rate(per 1000 female or male adults) in United Arab Emirates in 1968 to that in 1973?
Give a very brief answer. 1.13. What is the ratio of the Mortality Rate(per 1000 female or male adults) in East Asia (developing only) in 1968 to that in 1974?
Provide a succinct answer. 1.25. What is the ratio of the Mortality Rate(per 1000 female or male adults) of Sri Lanka in 1968 to that in 1974?
Your response must be concise. 1.08. What is the ratio of the Mortality Rate(per 1000 female or male adults) in United Arab Emirates in 1968 to that in 1974?
Provide a short and direct response. 1.16. What is the ratio of the Mortality Rate(per 1000 female or male adults) in East Asia (developing only) in 1968 to that in 1975?
Ensure brevity in your answer.  1.27. What is the ratio of the Mortality Rate(per 1000 female or male adults) of Sri Lanka in 1968 to that in 1975?
Ensure brevity in your answer.  1.1. What is the ratio of the Mortality Rate(per 1000 female or male adults) of United Arab Emirates in 1968 to that in 1975?
Give a very brief answer. 1.19. What is the ratio of the Mortality Rate(per 1000 female or male adults) of East Asia (developing only) in 1969 to that in 1970?
Provide a succinct answer. 1.05. What is the ratio of the Mortality Rate(per 1000 female or male adults) of Sri Lanka in 1969 to that in 1970?
Keep it short and to the point. 1.01. What is the ratio of the Mortality Rate(per 1000 female or male adults) in United Arab Emirates in 1969 to that in 1970?
Ensure brevity in your answer.  1.03. What is the ratio of the Mortality Rate(per 1000 female or male adults) of East Asia (developing only) in 1969 to that in 1971?
Provide a short and direct response. 1.1. What is the ratio of the Mortality Rate(per 1000 female or male adults) in Sri Lanka in 1969 to that in 1971?
Keep it short and to the point. 1.03. What is the ratio of the Mortality Rate(per 1000 female or male adults) in United Arab Emirates in 1969 to that in 1971?
Your answer should be compact. 1.05. What is the ratio of the Mortality Rate(per 1000 female or male adults) in East Asia (developing only) in 1969 to that in 1972?
Your answer should be compact. 1.15. What is the ratio of the Mortality Rate(per 1000 female or male adults) of Sri Lanka in 1969 to that in 1972?
Offer a very short reply. 1.04. What is the ratio of the Mortality Rate(per 1000 female or male adults) in United Arab Emirates in 1969 to that in 1972?
Provide a short and direct response. 1.08. What is the ratio of the Mortality Rate(per 1000 female or male adults) of East Asia (developing only) in 1969 to that in 1973?
Your answer should be very brief. 1.17. What is the ratio of the Mortality Rate(per 1000 female or male adults) of Sri Lanka in 1969 to that in 1973?
Your answer should be very brief. 1.06. What is the ratio of the Mortality Rate(per 1000 female or male adults) in United Arab Emirates in 1969 to that in 1973?
Provide a short and direct response. 1.11. What is the ratio of the Mortality Rate(per 1000 female or male adults) in East Asia (developing only) in 1969 to that in 1974?
Offer a terse response. 1.19. What is the ratio of the Mortality Rate(per 1000 female or male adults) in Sri Lanka in 1969 to that in 1974?
Offer a very short reply. 1.07. What is the ratio of the Mortality Rate(per 1000 female or male adults) in United Arab Emirates in 1969 to that in 1974?
Offer a very short reply. 1.13. What is the ratio of the Mortality Rate(per 1000 female or male adults) of East Asia (developing only) in 1969 to that in 1975?
Your answer should be compact. 1.22. What is the ratio of the Mortality Rate(per 1000 female or male adults) in Sri Lanka in 1969 to that in 1975?
Offer a terse response. 1.09. What is the ratio of the Mortality Rate(per 1000 female or male adults) of United Arab Emirates in 1969 to that in 1975?
Keep it short and to the point. 1.16. What is the ratio of the Mortality Rate(per 1000 female or male adults) in East Asia (developing only) in 1970 to that in 1971?
Make the answer very short. 1.05. What is the ratio of the Mortality Rate(per 1000 female or male adults) of Sri Lanka in 1970 to that in 1971?
Provide a short and direct response. 1.01. What is the ratio of the Mortality Rate(per 1000 female or male adults) of United Arab Emirates in 1970 to that in 1971?
Ensure brevity in your answer.  1.03. What is the ratio of the Mortality Rate(per 1000 female or male adults) of East Asia (developing only) in 1970 to that in 1972?
Keep it short and to the point. 1.1. What is the ratio of the Mortality Rate(per 1000 female or male adults) of Sri Lanka in 1970 to that in 1972?
Ensure brevity in your answer.  1.03. What is the ratio of the Mortality Rate(per 1000 female or male adults) in United Arab Emirates in 1970 to that in 1972?
Offer a very short reply. 1.05. What is the ratio of the Mortality Rate(per 1000 female or male adults) in East Asia (developing only) in 1970 to that in 1973?
Offer a terse response. 1.12. What is the ratio of the Mortality Rate(per 1000 female or male adults) in Sri Lanka in 1970 to that in 1973?
Your answer should be very brief. 1.04. What is the ratio of the Mortality Rate(per 1000 female or male adults) of United Arab Emirates in 1970 to that in 1973?
Offer a terse response. 1.08. What is the ratio of the Mortality Rate(per 1000 female or male adults) of East Asia (developing only) in 1970 to that in 1974?
Offer a terse response. 1.14. What is the ratio of the Mortality Rate(per 1000 female or male adults) in Sri Lanka in 1970 to that in 1974?
Offer a very short reply. 1.06. What is the ratio of the Mortality Rate(per 1000 female or male adults) of United Arab Emirates in 1970 to that in 1974?
Offer a very short reply. 1.11. What is the ratio of the Mortality Rate(per 1000 female or male adults) in East Asia (developing only) in 1970 to that in 1975?
Offer a terse response. 1.16. What is the ratio of the Mortality Rate(per 1000 female or male adults) of Sri Lanka in 1970 to that in 1975?
Provide a succinct answer. 1.07. What is the ratio of the Mortality Rate(per 1000 female or male adults) in United Arab Emirates in 1970 to that in 1975?
Provide a succinct answer. 1.13. What is the ratio of the Mortality Rate(per 1000 female or male adults) of East Asia (developing only) in 1971 to that in 1972?
Offer a terse response. 1.05. What is the ratio of the Mortality Rate(per 1000 female or male adults) of Sri Lanka in 1971 to that in 1972?
Offer a very short reply. 1.01. What is the ratio of the Mortality Rate(per 1000 female or male adults) of United Arab Emirates in 1971 to that in 1972?
Make the answer very short. 1.03. What is the ratio of the Mortality Rate(per 1000 female or male adults) of East Asia (developing only) in 1971 to that in 1973?
Your response must be concise. 1.07. What is the ratio of the Mortality Rate(per 1000 female or male adults) of Sri Lanka in 1971 to that in 1973?
Your answer should be very brief. 1.03. What is the ratio of the Mortality Rate(per 1000 female or male adults) of United Arab Emirates in 1971 to that in 1973?
Your answer should be compact. 1.05. What is the ratio of the Mortality Rate(per 1000 female or male adults) of East Asia (developing only) in 1971 to that in 1974?
Your answer should be compact. 1.09. What is the ratio of the Mortality Rate(per 1000 female or male adults) of Sri Lanka in 1971 to that in 1974?
Your answer should be very brief. 1.04. What is the ratio of the Mortality Rate(per 1000 female or male adults) of United Arab Emirates in 1971 to that in 1974?
Give a very brief answer. 1.08. What is the ratio of the Mortality Rate(per 1000 female or male adults) in East Asia (developing only) in 1971 to that in 1975?
Ensure brevity in your answer.  1.11. What is the ratio of the Mortality Rate(per 1000 female or male adults) in Sri Lanka in 1971 to that in 1975?
Provide a short and direct response. 1.06. What is the ratio of the Mortality Rate(per 1000 female or male adults) of United Arab Emirates in 1971 to that in 1975?
Give a very brief answer. 1.1. What is the ratio of the Mortality Rate(per 1000 female or male adults) of East Asia (developing only) in 1972 to that in 1973?
Offer a terse response. 1.02. What is the ratio of the Mortality Rate(per 1000 female or male adults) of Sri Lanka in 1972 to that in 1973?
Your answer should be very brief. 1.01. What is the ratio of the Mortality Rate(per 1000 female or male adults) of United Arab Emirates in 1972 to that in 1973?
Your answer should be very brief. 1.02. What is the ratio of the Mortality Rate(per 1000 female or male adults) of East Asia (developing only) in 1972 to that in 1974?
Provide a succinct answer. 1.04. What is the ratio of the Mortality Rate(per 1000 female or male adults) in Sri Lanka in 1972 to that in 1974?
Your response must be concise. 1.03. What is the ratio of the Mortality Rate(per 1000 female or male adults) of United Arab Emirates in 1972 to that in 1974?
Provide a succinct answer. 1.05. What is the ratio of the Mortality Rate(per 1000 female or male adults) of East Asia (developing only) in 1972 to that in 1975?
Your answer should be very brief. 1.06. What is the ratio of the Mortality Rate(per 1000 female or male adults) of Sri Lanka in 1972 to that in 1975?
Make the answer very short. 1.04. What is the ratio of the Mortality Rate(per 1000 female or male adults) in United Arab Emirates in 1972 to that in 1975?
Ensure brevity in your answer.  1.07. What is the ratio of the Mortality Rate(per 1000 female or male adults) of East Asia (developing only) in 1973 to that in 1974?
Your response must be concise. 1.02. What is the ratio of the Mortality Rate(per 1000 female or male adults) in Sri Lanka in 1973 to that in 1974?
Your answer should be very brief. 1.01. What is the ratio of the Mortality Rate(per 1000 female or male adults) in United Arab Emirates in 1973 to that in 1974?
Provide a succinct answer. 1.02. What is the ratio of the Mortality Rate(per 1000 female or male adults) in East Asia (developing only) in 1973 to that in 1975?
Your response must be concise. 1.04. What is the ratio of the Mortality Rate(per 1000 female or male adults) in Sri Lanka in 1973 to that in 1975?
Give a very brief answer. 1.03. What is the ratio of the Mortality Rate(per 1000 female or male adults) in United Arab Emirates in 1973 to that in 1975?
Your answer should be compact. 1.05. What is the ratio of the Mortality Rate(per 1000 female or male adults) of East Asia (developing only) in 1974 to that in 1975?
Keep it short and to the point. 1.02. What is the ratio of the Mortality Rate(per 1000 female or male adults) of Sri Lanka in 1974 to that in 1975?
Provide a short and direct response. 1.01. What is the ratio of the Mortality Rate(per 1000 female or male adults) in United Arab Emirates in 1974 to that in 1975?
Keep it short and to the point. 1.02. What is the difference between the highest and the second highest Mortality Rate(per 1000 female or male adults) of East Asia (developing only)?
Offer a terse response. 9.84. What is the difference between the highest and the second highest Mortality Rate(per 1000 female or male adults) in Sri Lanka?
Ensure brevity in your answer.  2.26. What is the difference between the highest and the second highest Mortality Rate(per 1000 female or male adults) in United Arab Emirates?
Ensure brevity in your answer.  4.99. What is the difference between the highest and the lowest Mortality Rate(per 1000 female or male adults) in East Asia (developing only)?
Offer a very short reply. 49.33. What is the difference between the highest and the lowest Mortality Rate(per 1000 female or male adults) in Sri Lanka?
Provide a succinct answer. 16.05. What is the difference between the highest and the lowest Mortality Rate(per 1000 female or male adults) in United Arab Emirates?
Ensure brevity in your answer.  32.88. 